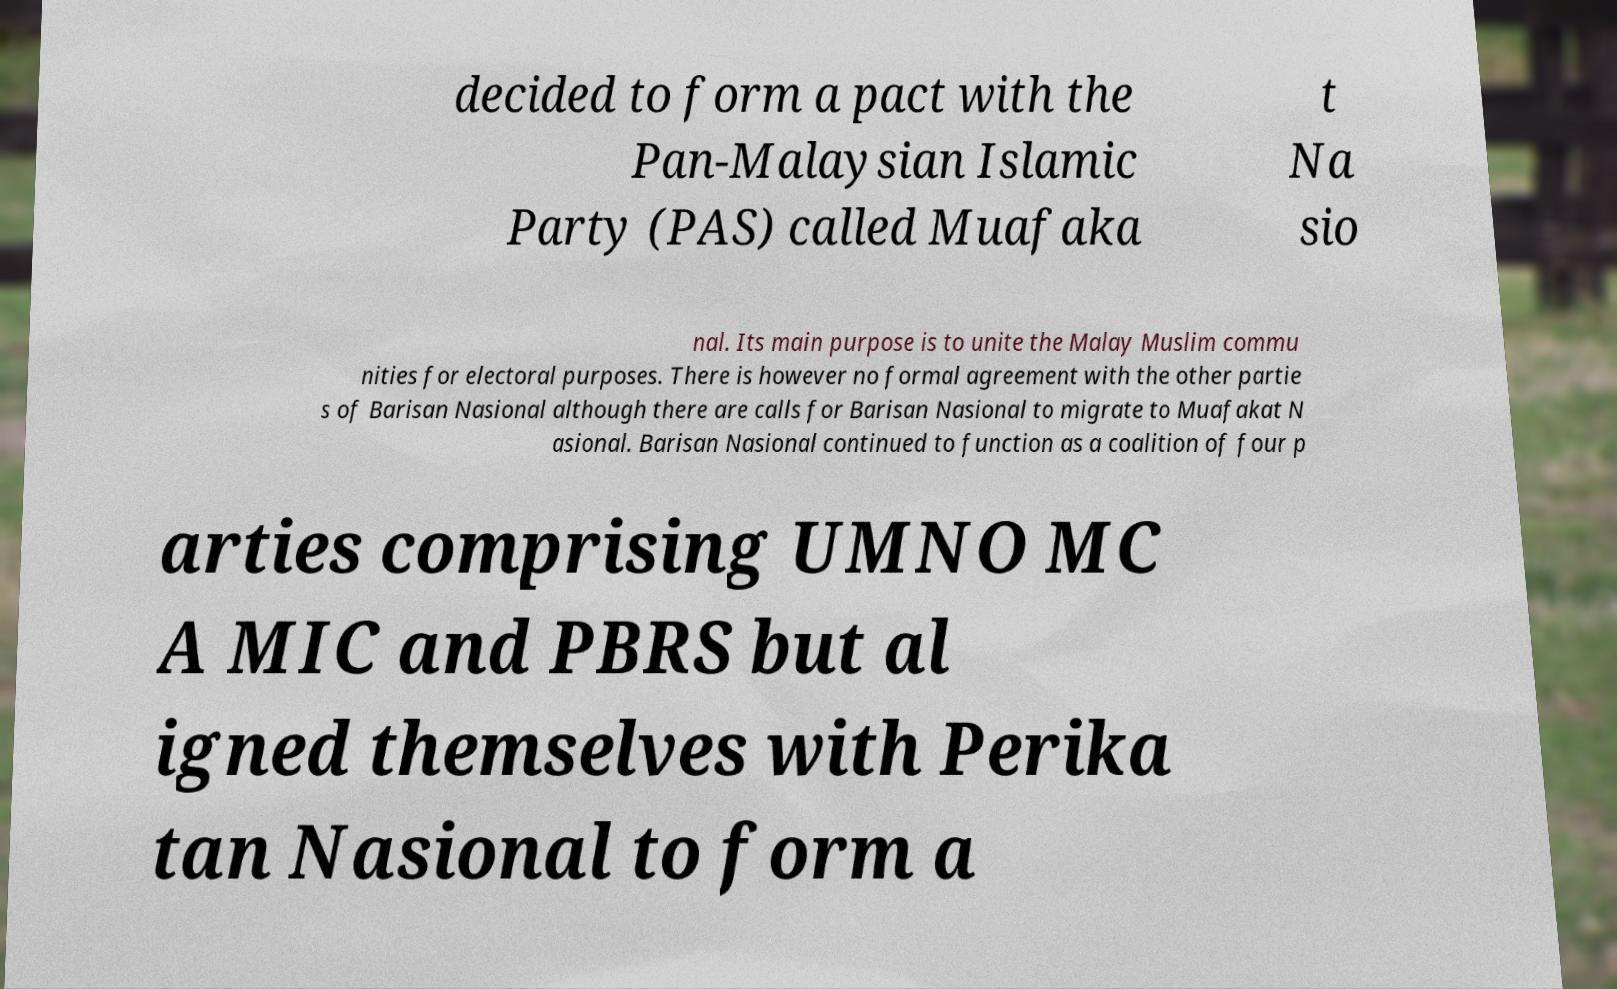Could you assist in decoding the text presented in this image and type it out clearly? decided to form a pact with the Pan-Malaysian Islamic Party (PAS) called Muafaka t Na sio nal. Its main purpose is to unite the Malay Muslim commu nities for electoral purposes. There is however no formal agreement with the other partie s of Barisan Nasional although there are calls for Barisan Nasional to migrate to Muafakat N asional. Barisan Nasional continued to function as a coalition of four p arties comprising UMNO MC A MIC and PBRS but al igned themselves with Perika tan Nasional to form a 